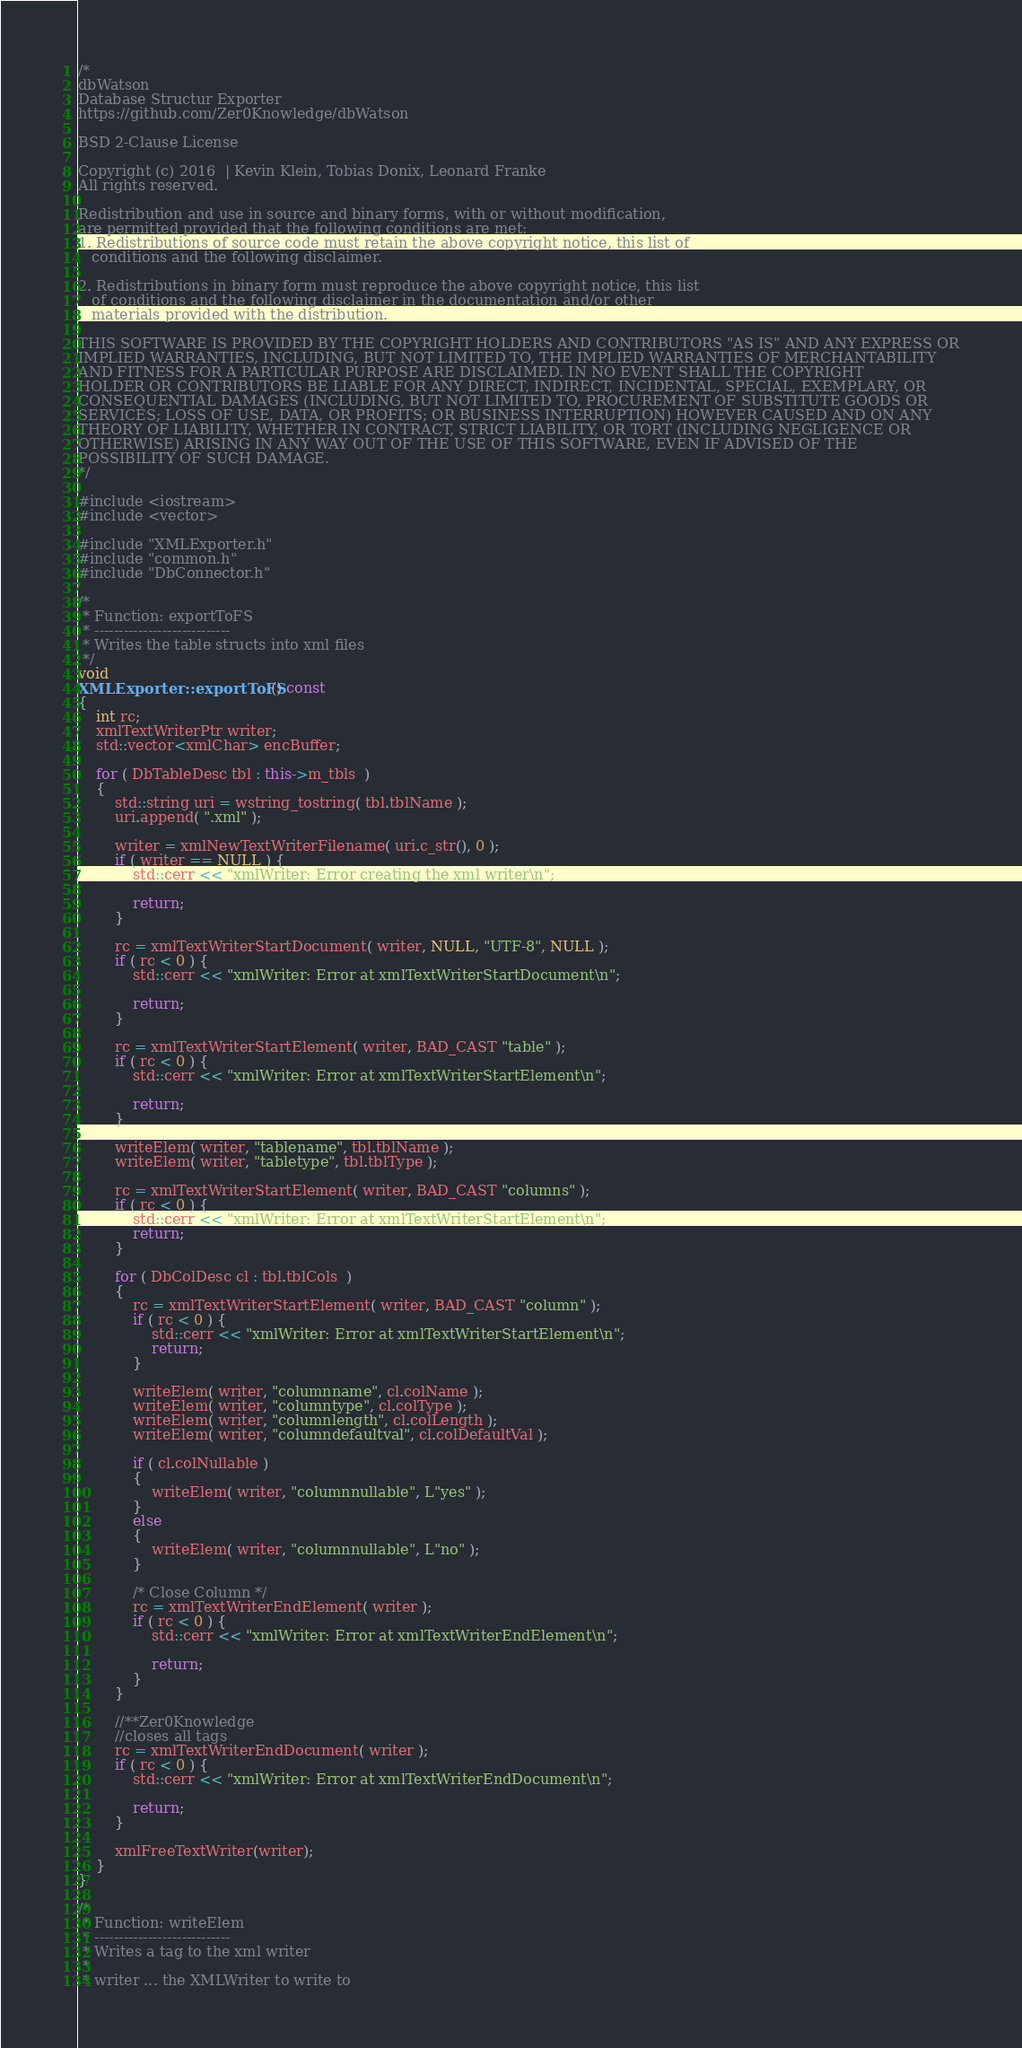<code> <loc_0><loc_0><loc_500><loc_500><_C++_>/*
dbWatson
Database Structur Exporter
https://github.com/Zer0Knowledge/dbWatson

BSD 2-Clause License

Copyright (c) 2016  | Kevin Klein, Tobias Donix, Leonard Franke
All rights reserved.

Redistribution and use in source and binary forms, with or without modification,
are permitted provided that the following conditions are met:
1. Redistributions of source code must retain the above copyright notice, this list of
   conditions and the following disclaimer.

2. Redistributions in binary form must reproduce the above copyright notice, this list
   of conditions and the following disclaimer in the documentation and/or other
   materials provided with the distribution.

THIS SOFTWARE IS PROVIDED BY THE COPYRIGHT HOLDERS AND CONTRIBUTORS "AS IS" AND ANY EXPRESS OR
IMPLIED WARRANTIES, INCLUDING, BUT NOT LIMITED TO, THE IMPLIED WARRANTIES OF MERCHANTABILITY
AND FITNESS FOR A PARTICULAR PURPOSE ARE DISCLAIMED. IN NO EVENT SHALL THE COPYRIGHT
HOLDER OR CONTRIBUTORS BE LIABLE FOR ANY DIRECT, INDIRECT, INCIDENTAL, SPECIAL, EXEMPLARY, OR
CONSEQUENTIAL DAMAGES (INCLUDING, BUT NOT LIMITED TO, PROCUREMENT OF SUBSTITUTE GOODS OR
SERVICES; LOSS OF USE, DATA, OR PROFITS; OR BUSINESS INTERRUPTION) HOWEVER CAUSED AND ON ANY
THEORY OF LIABILITY, WHETHER IN CONTRACT, STRICT LIABILITY, OR TORT (INCLUDING NEGLIGENCE OR
OTHERWISE) ARISING IN ANY WAY OUT OF THE USE OF THIS SOFTWARE, EVEN IF ADVISED OF THE
POSSIBILITY OF SUCH DAMAGE.
*/

#include <iostream>
#include <vector>

#include "XMLExporter.h"
#include "common.h"
#include "DbConnector.h"

/*
 * Function: exportToFS
 * ----------------------------
 * Writes the table structs into xml files
 */
void
XMLExporter::exportToFS() const
{  
	int rc;
	xmlTextWriterPtr writer;
	std::vector<xmlChar> encBuffer;
  
	for ( DbTableDesc tbl : this->m_tbls  )
    {
        std::string uri = wstring_tostring( tbl.tblName );
		uri.append( ".xml" );
				       
		writer = xmlNewTextWriterFilename( uri.c_str(), 0 );
		if ( writer == NULL ) {
			std::cerr << "xmlWriter: Error creating the xml writer\n";
			
			return;
		}
		
		rc = xmlTextWriterStartDocument( writer, NULL, "UTF-8", NULL );
		if ( rc < 0 ) {
			std::cerr << "xmlWriter: Error at xmlTextWriterStartDocument\n";
			
			return;
		}
		
		rc = xmlTextWriterStartElement( writer, BAD_CAST "table" );
		if ( rc < 0 ) {
			std::cerr << "xmlWriter: Error at xmlTextWriterStartElement\n";
			
			return;
		}
		
		writeElem( writer, "tablename", tbl.tblName );
		writeElem( writer, "tabletype", tbl.tblType );
		
		rc = xmlTextWriterStartElement( writer, BAD_CAST "columns" );
		if ( rc < 0 ) {
			std::cerr << "xmlWriter: Error at xmlTextWriterStartElement\n";
			return;
		}

		for ( DbColDesc cl : tbl.tblCols  )
		{
			rc = xmlTextWriterStartElement( writer, BAD_CAST "column" );
			if ( rc < 0 ) {
				std::cerr << "xmlWriter: Error at xmlTextWriterStartElement\n";
				return;
			}
			
			writeElem( writer, "columnname", cl.colName );
			writeElem( writer, "columntype", cl.colType );
			writeElem( writer, "columnlength", cl.colLength );
			writeElem( writer, "columndefaultval", cl.colDefaultVal );
			
			if ( cl.colNullable )
			{
				writeElem( writer, "columnnullable", L"yes" );
			}
			else
			{
				writeElem( writer, "columnnullable", L"no" );
			}
			
			/* Close Column */
			rc = xmlTextWriterEndElement( writer );
			if ( rc < 0 ) {
				std::cerr << "xmlWriter: Error at xmlTextWriterEndElement\n";
				
				return;
			}
		}

		//**Zer0Knowledge
		//closes all tags
		rc = xmlTextWriterEndDocument( writer );
		if ( rc < 0 ) {
			std::cerr << "xmlWriter: Error at xmlTextWriterEndDocument\n";
			
			return;
		}
		
		xmlFreeTextWriter(writer);
    }
}

/*
 * Function: writeElem
 * ----------------------------
 * Writes a tag to the xml writer
 *
 * writer ... the XMLWriter to write to</code> 